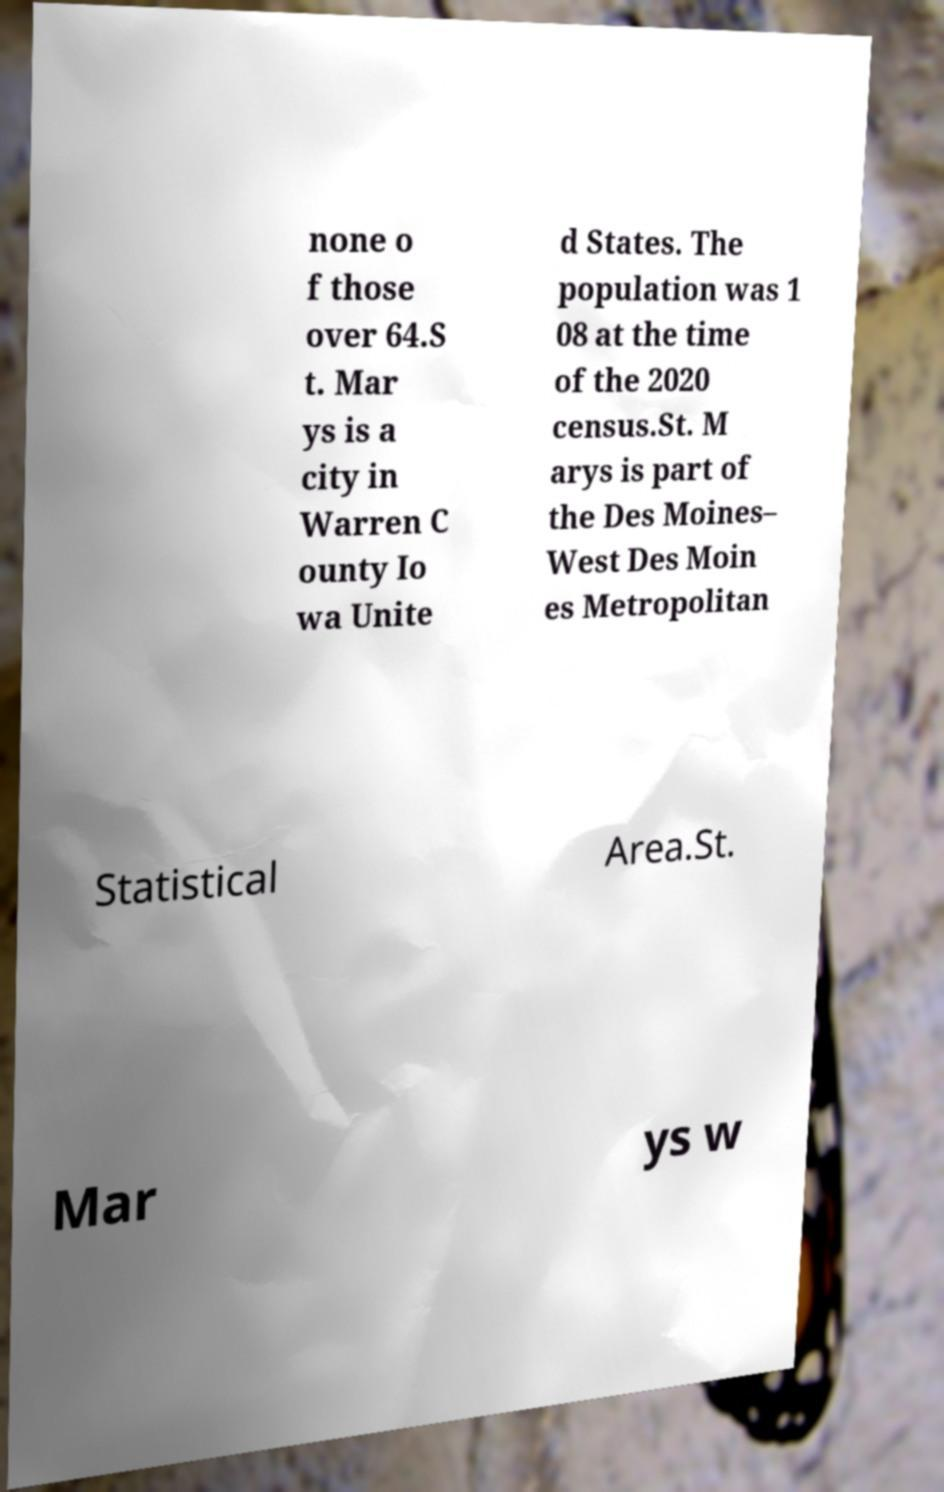For documentation purposes, I need the text within this image transcribed. Could you provide that? none o f those over 64.S t. Mar ys is a city in Warren C ounty Io wa Unite d States. The population was 1 08 at the time of the 2020 census.St. M arys is part of the Des Moines– West Des Moin es Metropolitan Statistical Area.St. Mar ys w 